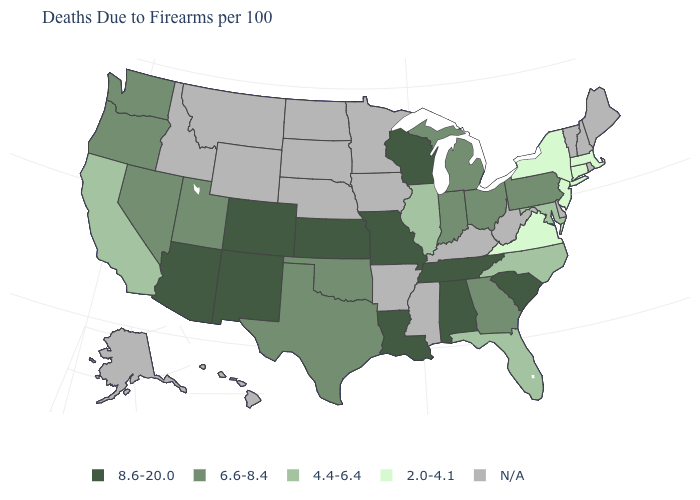What is the value of Wyoming?
Concise answer only. N/A. What is the value of Illinois?
Answer briefly. 4.4-6.4. Name the states that have a value in the range 4.4-6.4?
Answer briefly. California, Florida, Illinois, Maryland, North Carolina. Name the states that have a value in the range 6.6-8.4?
Concise answer only. Georgia, Indiana, Michigan, Nevada, Ohio, Oklahoma, Oregon, Pennsylvania, Texas, Utah, Washington. Is the legend a continuous bar?
Answer briefly. No. Is the legend a continuous bar?
Quick response, please. No. What is the value of Louisiana?
Write a very short answer. 8.6-20.0. What is the value of Montana?
Quick response, please. N/A. Among the states that border Tennessee , which have the lowest value?
Keep it brief. Virginia. Name the states that have a value in the range 6.6-8.4?
Be succinct. Georgia, Indiana, Michigan, Nevada, Ohio, Oklahoma, Oregon, Pennsylvania, Texas, Utah, Washington. Name the states that have a value in the range 8.6-20.0?
Concise answer only. Alabama, Arizona, Colorado, Kansas, Louisiana, Missouri, New Mexico, South Carolina, Tennessee, Wisconsin. What is the highest value in the USA?
Be succinct. 8.6-20.0. Among the states that border Michigan , does Wisconsin have the lowest value?
Short answer required. No. 